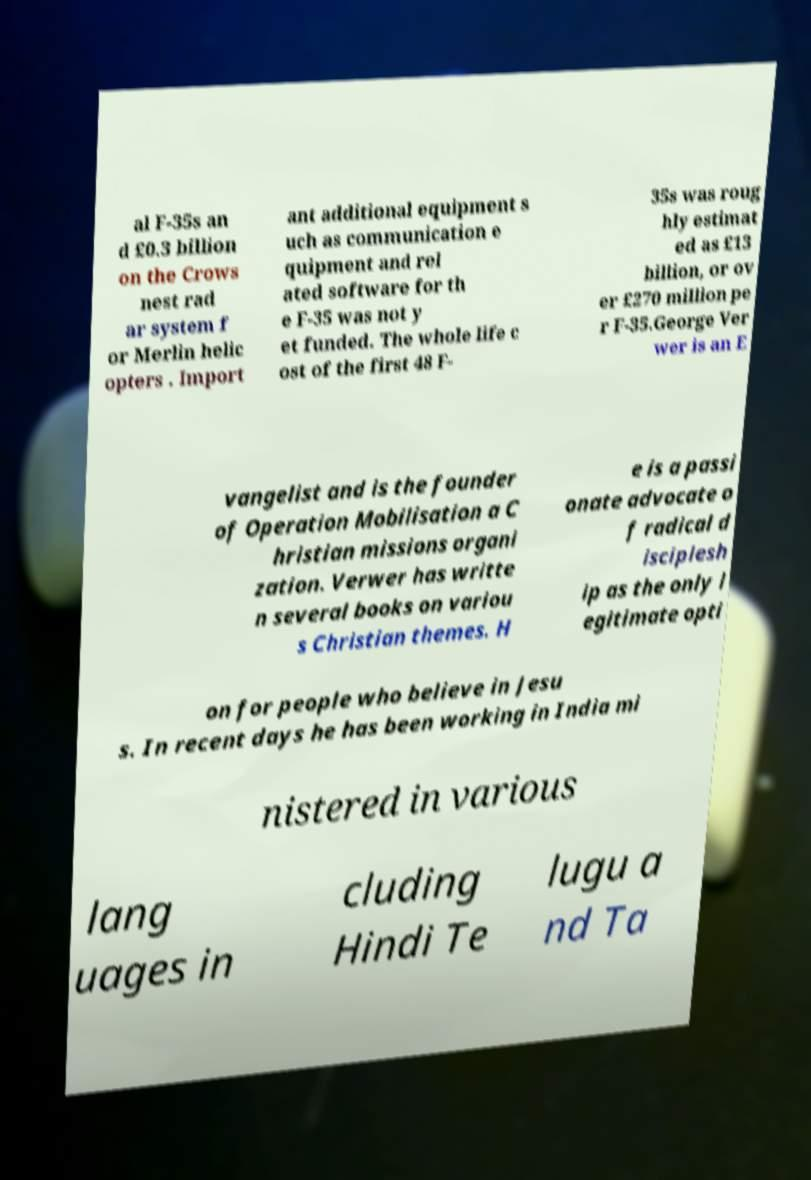I need the written content from this picture converted into text. Can you do that? al F-35s an d £0.3 billion on the Crows nest rad ar system f or Merlin helic opters . Import ant additional equipment s uch as communication e quipment and rel ated software for th e F-35 was not y et funded. The whole life c ost of the first 48 F- 35s was roug hly estimat ed as £13 billion, or ov er £270 million pe r F-35.George Ver wer is an E vangelist and is the founder of Operation Mobilisation a C hristian missions organi zation. Verwer has writte n several books on variou s Christian themes. H e is a passi onate advocate o f radical d isciplesh ip as the only l egitimate opti on for people who believe in Jesu s. In recent days he has been working in India mi nistered in various lang uages in cluding Hindi Te lugu a nd Ta 